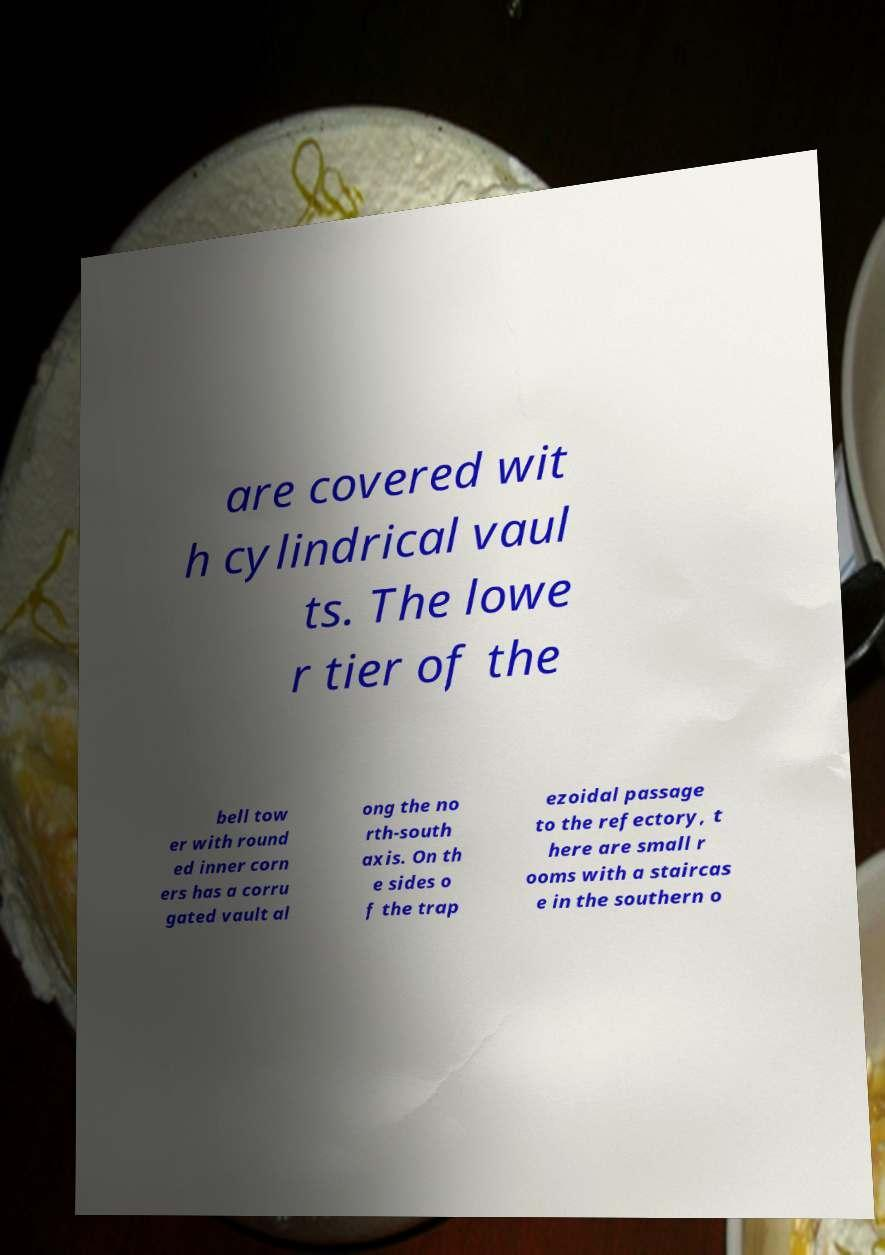Please read and relay the text visible in this image. What does it say? are covered wit h cylindrical vaul ts. The lowe r tier of the bell tow er with round ed inner corn ers has a corru gated vault al ong the no rth-south axis. On th e sides o f the trap ezoidal passage to the refectory, t here are small r ooms with a staircas e in the southern o 